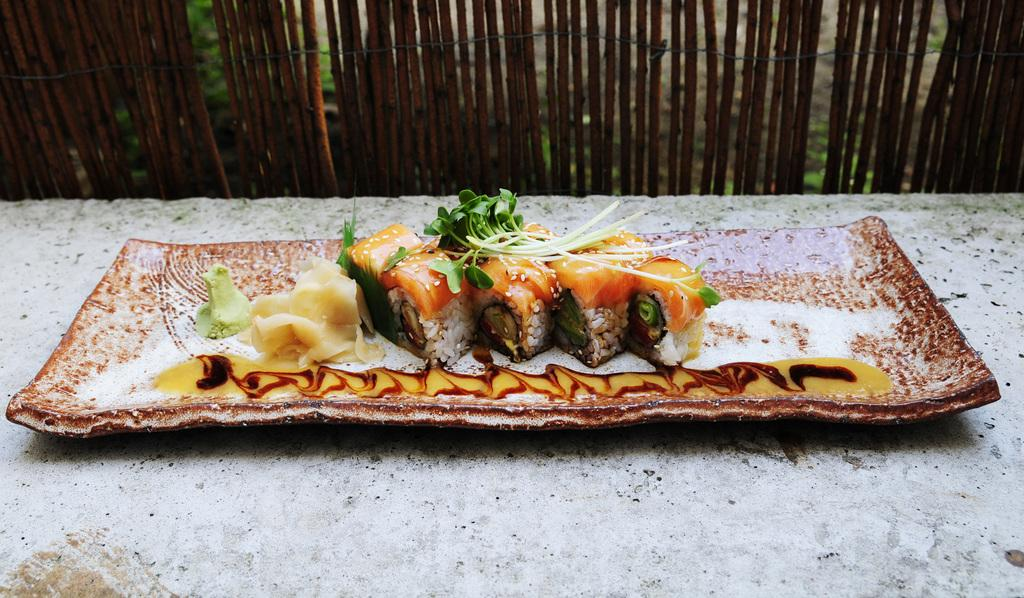What is on the plate that is visible in the image? There is food on a plate in the image. Where is the plate located? The plate is on a rock in the image. What can be seen in the background of the image? There are small stems in brown color in the background of the image. What type of copper utensil is being used to cut the meat in the image? There is no copper utensil or meat present in the image. 